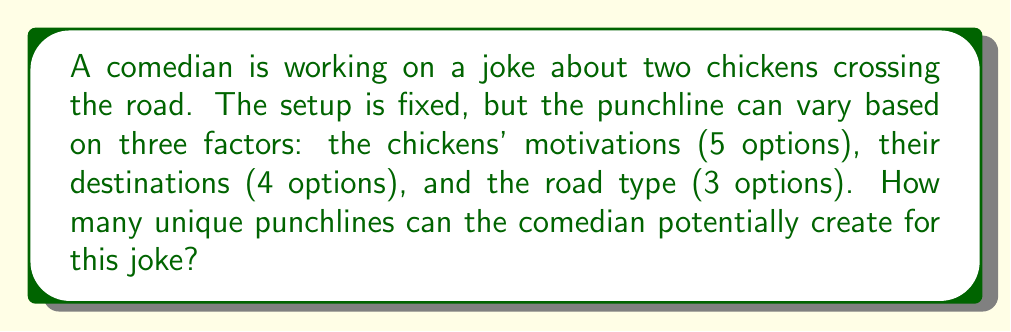Can you solve this math problem? Let's approach this step-by-step:

1) We have three independent factors that can be combined to create a punchline:
   - Chickens' motivations: 5 options
   - Destinations: 4 options
   - Road types: 3 options

2) To find the total number of possible combinations, we use the multiplication principle of counting. This principle states that if we have $m$ ways of doing something, $n$ ways of doing another thing, and $p$ ways of doing a third thing, then there are $m \times n \times p$ ways to do all three things.

3) In this case:
   $$ \text{Total combinations} = 5 \times 4 \times 3 $$

4) Let's calculate:
   $$ 5 \times 4 \times 3 = 20 \times 3 = 60 $$

Therefore, the comedian can potentially create 60 unique punchlines for this joke setup.
Answer: 60 